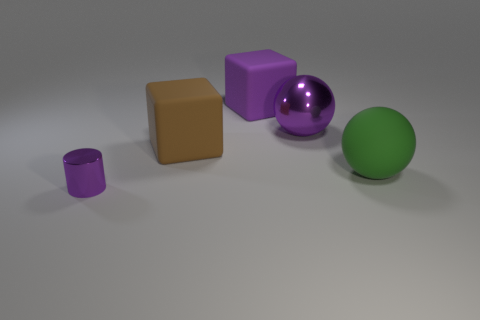There is a block that is the same color as the metal sphere; what is its size?
Provide a succinct answer. Large. There is a purple thing that is made of the same material as the purple cylinder; what is its size?
Provide a succinct answer. Large. Does the tiny thing to the left of the purple rubber block have the same color as the large shiny thing?
Keep it short and to the point. Yes. There is a purple metallic thing behind the metal thing that is in front of the big metal object; how many large metallic things are right of it?
Give a very brief answer. 0. What number of large blocks are behind the brown matte block and in front of the purple block?
Offer a terse response. 0. What shape is the big matte thing that is the same color as the big metallic thing?
Your answer should be compact. Cube. Do the small purple object and the purple ball have the same material?
Provide a short and direct response. Yes. What is the shape of the big rubber object in front of the brown matte block to the left of the metallic object that is behind the big green matte ball?
Your response must be concise. Sphere. Is the number of purple shiny balls to the left of the small purple cylinder less than the number of tiny purple metallic objects behind the brown object?
Provide a short and direct response. No. What shape is the large purple thing to the left of the metal object that is behind the tiny metal cylinder?
Your answer should be compact. Cube. 